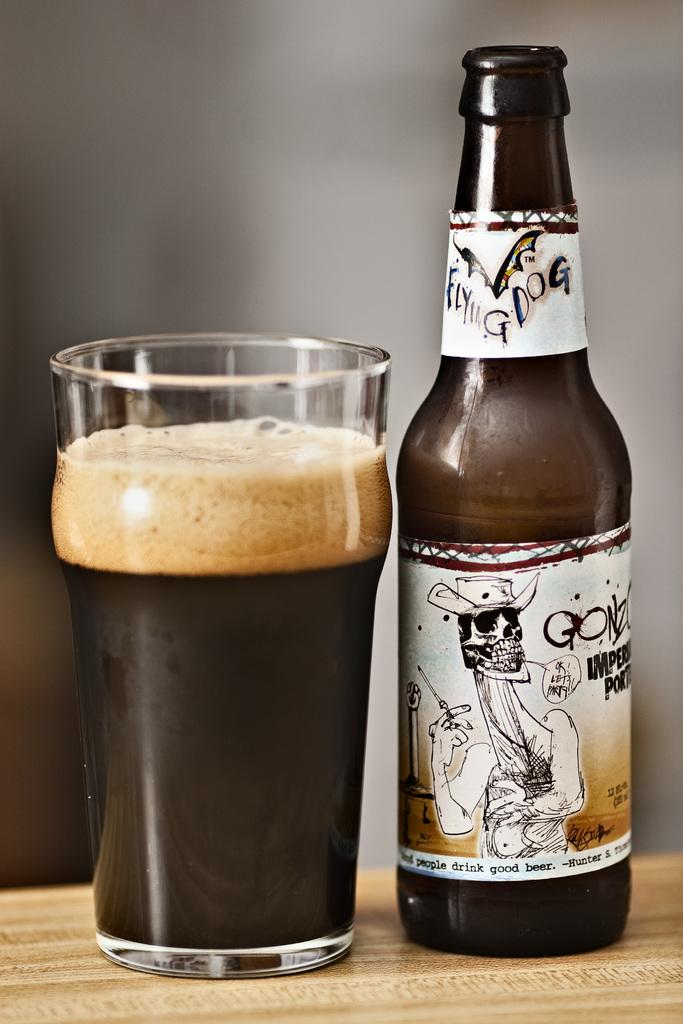<image>
Write a terse but informative summary of the picture. An open bottle of Flying dog branded beer next to a filled glass. 